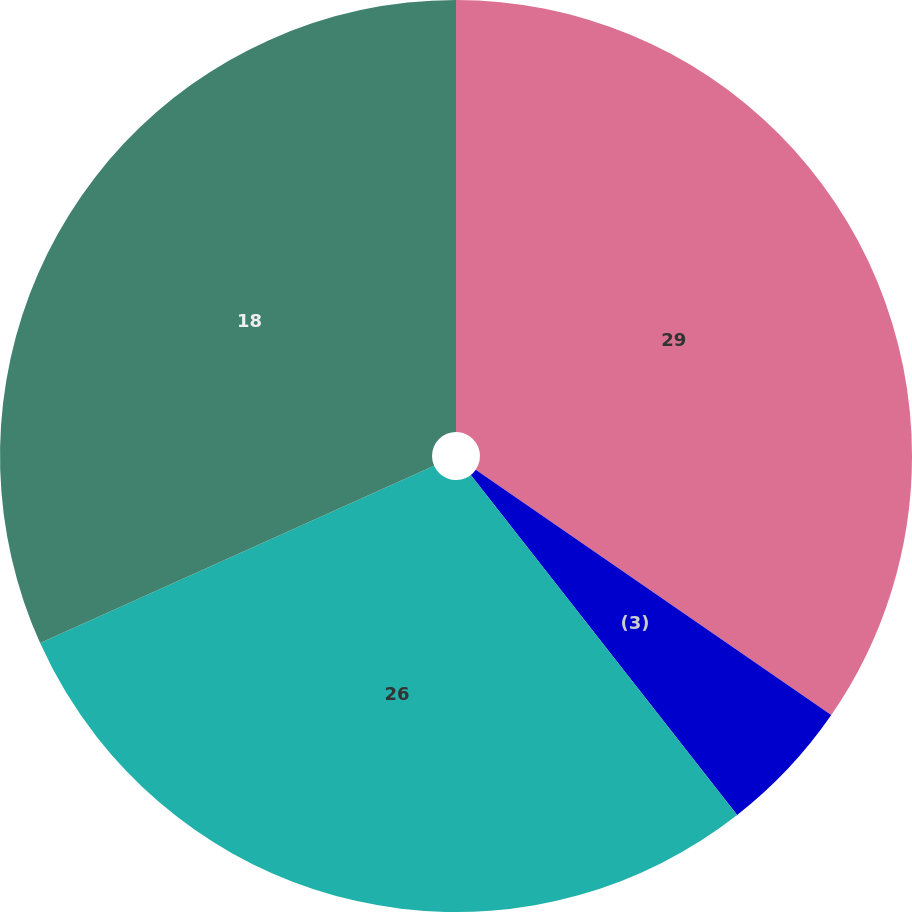Convert chart to OTSL. <chart><loc_0><loc_0><loc_500><loc_500><pie_chart><fcel>29<fcel>(3)<fcel>26<fcel>18<nl><fcel>34.62%<fcel>4.81%<fcel>28.85%<fcel>31.73%<nl></chart> 